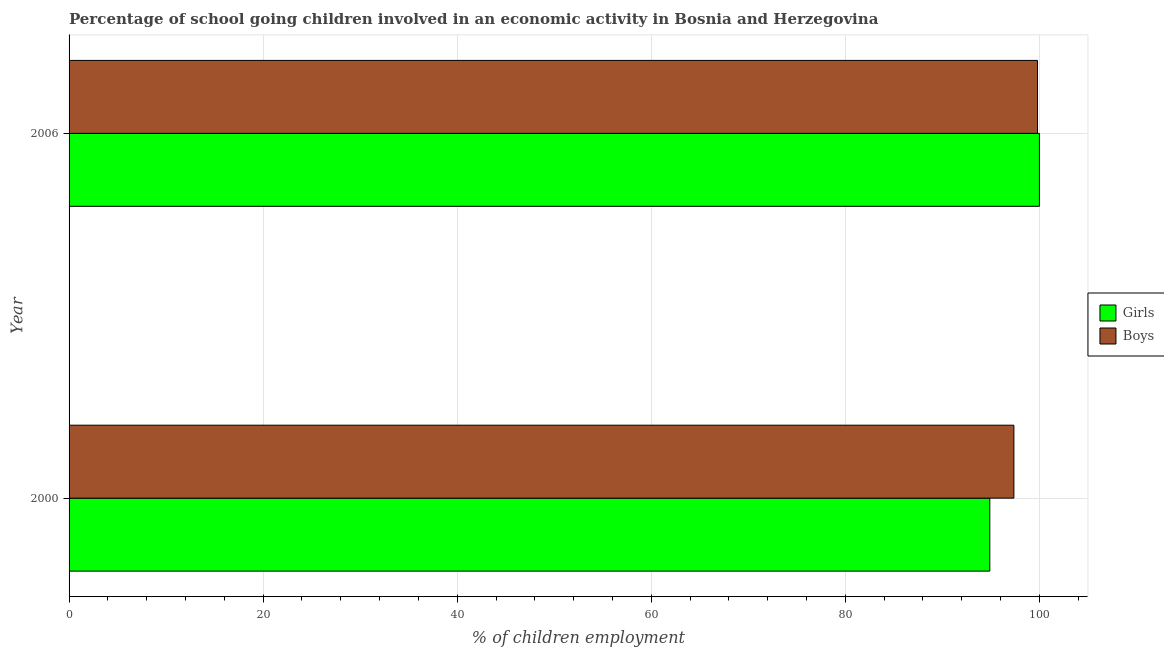How many different coloured bars are there?
Your answer should be very brief. 2. How many groups of bars are there?
Your response must be concise. 2. Are the number of bars on each tick of the Y-axis equal?
Keep it short and to the point. Yes. How many bars are there on the 2nd tick from the top?
Offer a very short reply. 2. What is the label of the 1st group of bars from the top?
Give a very brief answer. 2006. What is the percentage of school going boys in 2006?
Give a very brief answer. 99.8. Across all years, what is the maximum percentage of school going girls?
Give a very brief answer. 100. Across all years, what is the minimum percentage of school going girls?
Provide a short and direct response. 94.89. In which year was the percentage of school going boys minimum?
Provide a short and direct response. 2000. What is the total percentage of school going boys in the graph?
Make the answer very short. 197.17. What is the difference between the percentage of school going boys in 2000 and that in 2006?
Make the answer very short. -2.43. What is the difference between the percentage of school going girls in 2000 and the percentage of school going boys in 2006?
Your answer should be very brief. -4.91. What is the average percentage of school going girls per year?
Provide a succinct answer. 97.44. In how many years, is the percentage of school going boys greater than 64 %?
Keep it short and to the point. 2. Is the percentage of school going girls in 2000 less than that in 2006?
Provide a short and direct response. Yes. Is the difference between the percentage of school going girls in 2000 and 2006 greater than the difference between the percentage of school going boys in 2000 and 2006?
Give a very brief answer. No. What does the 1st bar from the top in 2000 represents?
Provide a succinct answer. Boys. What does the 1st bar from the bottom in 2006 represents?
Keep it short and to the point. Girls. How many bars are there?
Keep it short and to the point. 4. Does the graph contain any zero values?
Keep it short and to the point. No. How many legend labels are there?
Give a very brief answer. 2. How are the legend labels stacked?
Your response must be concise. Vertical. What is the title of the graph?
Offer a very short reply. Percentage of school going children involved in an economic activity in Bosnia and Herzegovina. Does "Under-five" appear as one of the legend labels in the graph?
Your answer should be very brief. No. What is the label or title of the X-axis?
Offer a terse response. % of children employment. What is the % of children employment of Girls in 2000?
Keep it short and to the point. 94.89. What is the % of children employment in Boys in 2000?
Your answer should be compact. 97.37. What is the % of children employment of Boys in 2006?
Your answer should be very brief. 99.8. Across all years, what is the maximum % of children employment of Boys?
Ensure brevity in your answer.  99.8. Across all years, what is the minimum % of children employment in Girls?
Your response must be concise. 94.89. Across all years, what is the minimum % of children employment in Boys?
Give a very brief answer. 97.37. What is the total % of children employment of Girls in the graph?
Offer a very short reply. 194.89. What is the total % of children employment of Boys in the graph?
Provide a succinct answer. 197.17. What is the difference between the % of children employment in Girls in 2000 and that in 2006?
Your answer should be compact. -5.11. What is the difference between the % of children employment of Boys in 2000 and that in 2006?
Your answer should be compact. -2.43. What is the difference between the % of children employment of Girls in 2000 and the % of children employment of Boys in 2006?
Offer a terse response. -4.91. What is the average % of children employment of Girls per year?
Make the answer very short. 97.44. What is the average % of children employment of Boys per year?
Offer a terse response. 98.58. In the year 2000, what is the difference between the % of children employment in Girls and % of children employment in Boys?
Your answer should be very brief. -2.48. What is the ratio of the % of children employment of Girls in 2000 to that in 2006?
Provide a short and direct response. 0.95. What is the ratio of the % of children employment in Boys in 2000 to that in 2006?
Provide a short and direct response. 0.98. What is the difference between the highest and the second highest % of children employment in Girls?
Give a very brief answer. 5.11. What is the difference between the highest and the second highest % of children employment of Boys?
Give a very brief answer. 2.43. What is the difference between the highest and the lowest % of children employment in Girls?
Provide a succinct answer. 5.11. What is the difference between the highest and the lowest % of children employment in Boys?
Offer a terse response. 2.43. 